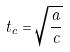<formula> <loc_0><loc_0><loc_500><loc_500>t _ { c } = \sqrt { \frac { a } { c } }</formula> 